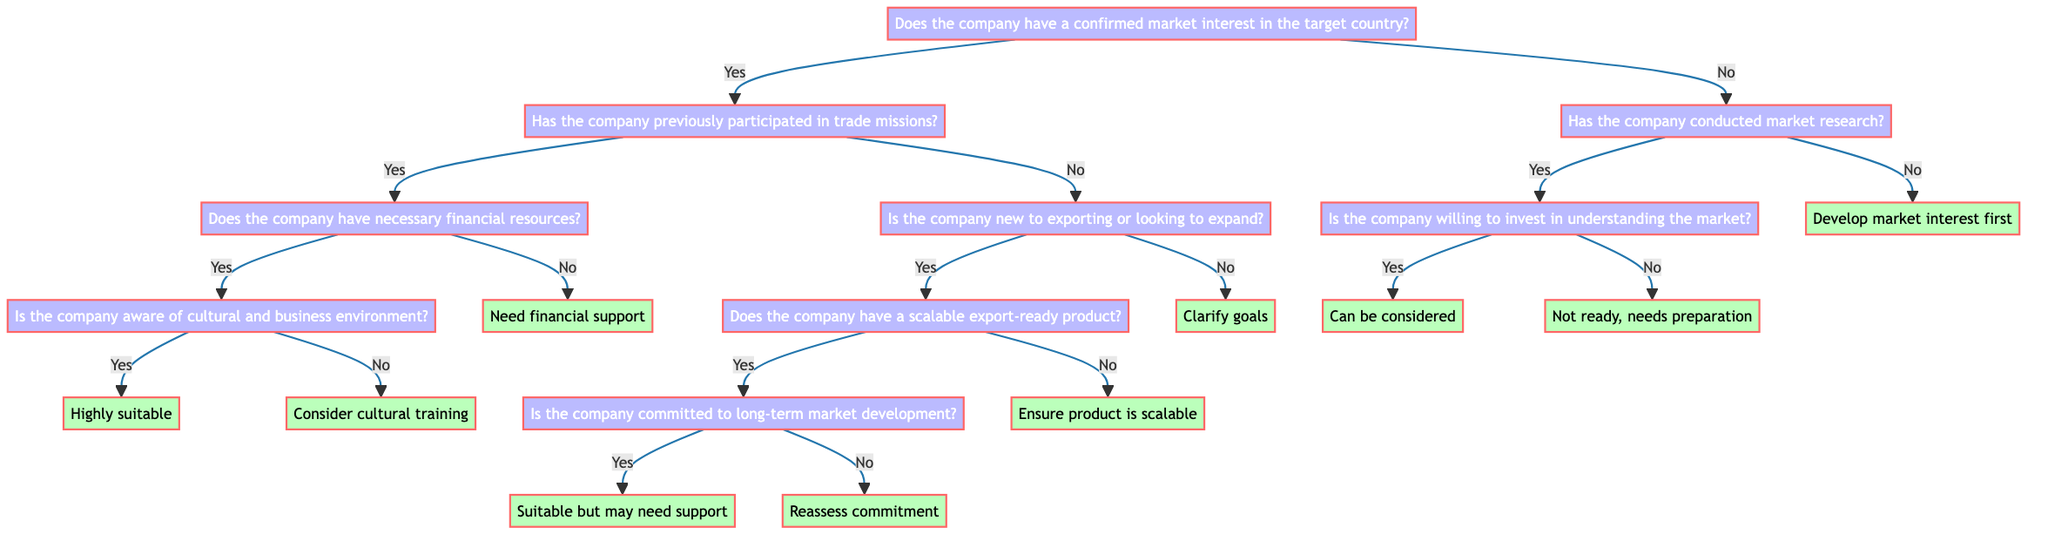Does the company have a confirmed market interest in the target country? This is the root question of the decision tree. It determines the initial path. If the answer is ‘Yes’, it leads to the next question about prior participation in trade missions; if ‘No’, it leads to questions about market research.
Answer: Yes What is the consequence if the company has previously participated in trade missions? If the answer to the prior question is ‘Yes’ and the company previously participated in trade missions, it leads to a question regarding financial resources, helping assess suitability for upcoming missions.
Answer: Financial resources What will happen if the company does not have financial resources? If the company answers ‘No’ to having necessary financial resources after already confirming market interest, it leads to a note indicating that the company needs financial support or resources to participate in trade missions.
Answer: Needs financial support What are the potential outcomes if the company is committed to long-term market development? If the company confirms it has a scalable export-ready product and is committed to long-term development, it will be categorized as suitable for the trade mission but may benefit from additional market entry support.
Answer: Suitable but may need support What happens if the company conducted market research but is not willing to invest in understanding the market? If the company answers ‘Yes’ to conducting market research but ‘No’ to willingness to invest resources, it indicates the company might not be ready for a trade mission and requires further preparation.
Answer: Not ready, needs preparation Is there a specific question regarding cultural understanding that leads to a highly suitable outcome? Yes, if the company has confirmed financial resources and is aware of the cultural and business environment after confirming market interest and prior participation in trade missions, it leads to a highly suitable classification for the trade mission.
Answer: Highly suitable What does it indicate if the company is not new to exporting but doesn't have market interest? If the company is not new to exporting and also does not have confirmed market interest, the flow indicates the company should first clarify its goals before participating in the trade mission.
Answer: Clarify goals How many main questions are present in the decision tree? The decision tree consists of eight main questions that guide the assessment process for determining suitability for trade missions, which can be identified as separate nodes in the flow.
Answer: Eight What is the outcome if the company has not conducted any market research? If a company does not have a confirmed market interest and has not done market research, it leads to a recommendation that the company should develop an interest or conduct research on the target country before considering a trade mission.
Answer: Develop market interest first 